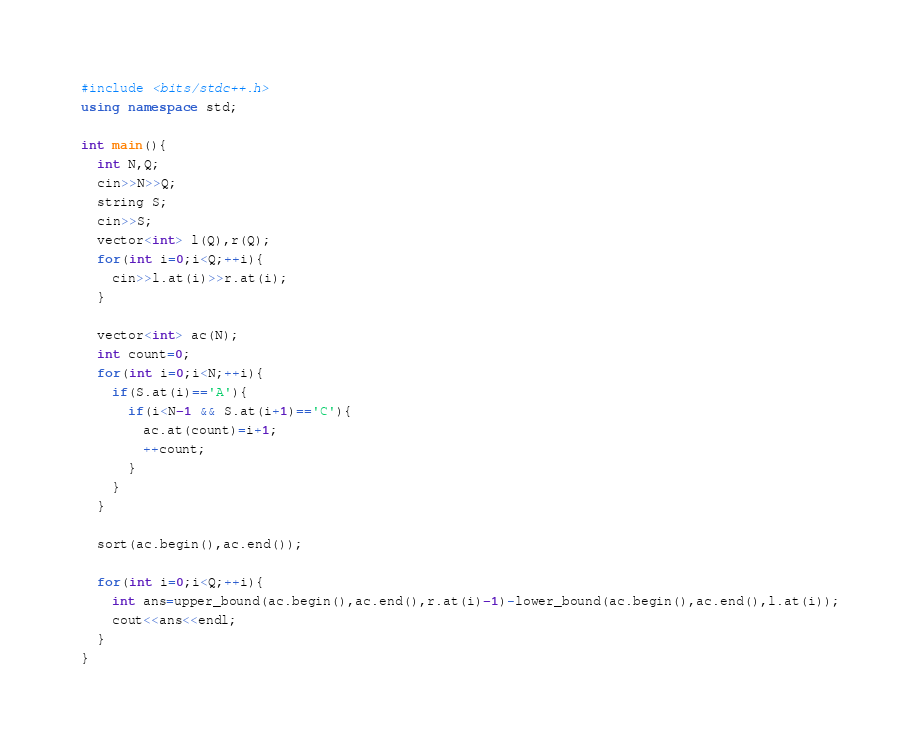<code> <loc_0><loc_0><loc_500><loc_500><_C++_>#include <bits/stdc++.h>
using namespace std;
 
int main(){
  int N,Q;
  cin>>N>>Q;
  string S;
  cin>>S;
  vector<int> l(Q),r(Q);
  for(int i=0;i<Q;++i){
    cin>>l.at(i)>>r.at(i);
  }
 
  vector<int> ac(N);
  int count=0;
  for(int i=0;i<N;++i){
    if(S.at(i)=='A'){
      if(i<N-1 && S.at(i+1)=='C'){
        ac.at(count)=i+1;
        ++count;
      }
    }
  }
  
  sort(ac.begin(),ac.end());
 
  for(int i=0;i<Q;++i){
    int ans=upper_bound(ac.begin(),ac.end(),r.at(i)-1)-lower_bound(ac.begin(),ac.end(),l.at(i));
    cout<<ans<<endl;
  }
}</code> 